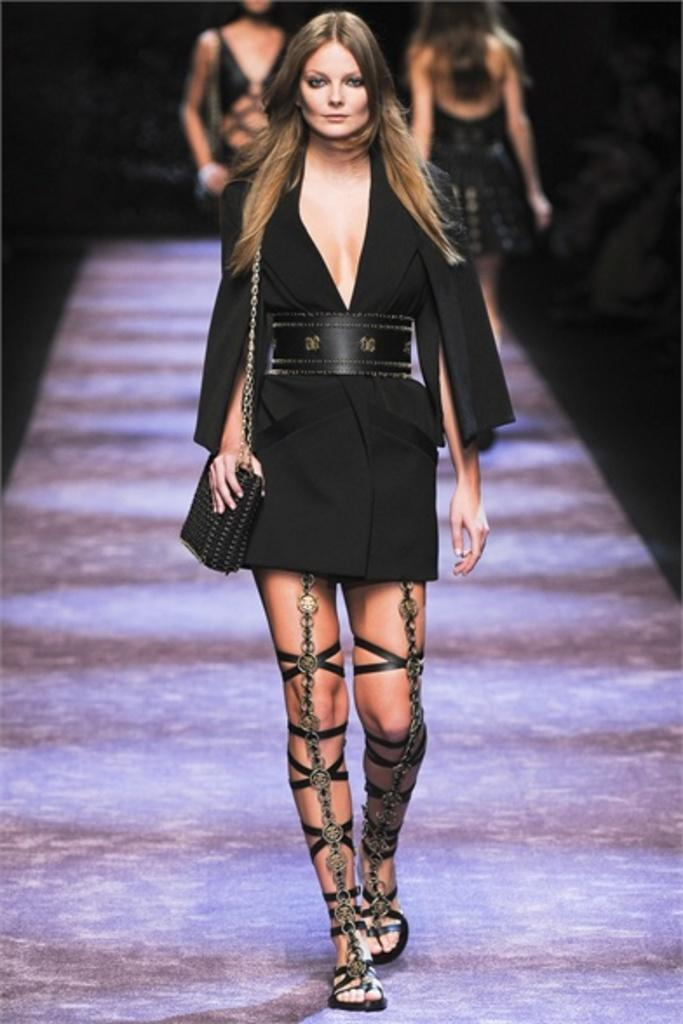How many women are present in the image? There are three women in the image. What color are the dresses worn by the women? The women are wearing black color dresses. What are the women doing in the image? The women are walking. What type of honey is being served by the women in the image? There is no honey present in the image; the women are wearing black dresses and walking. 